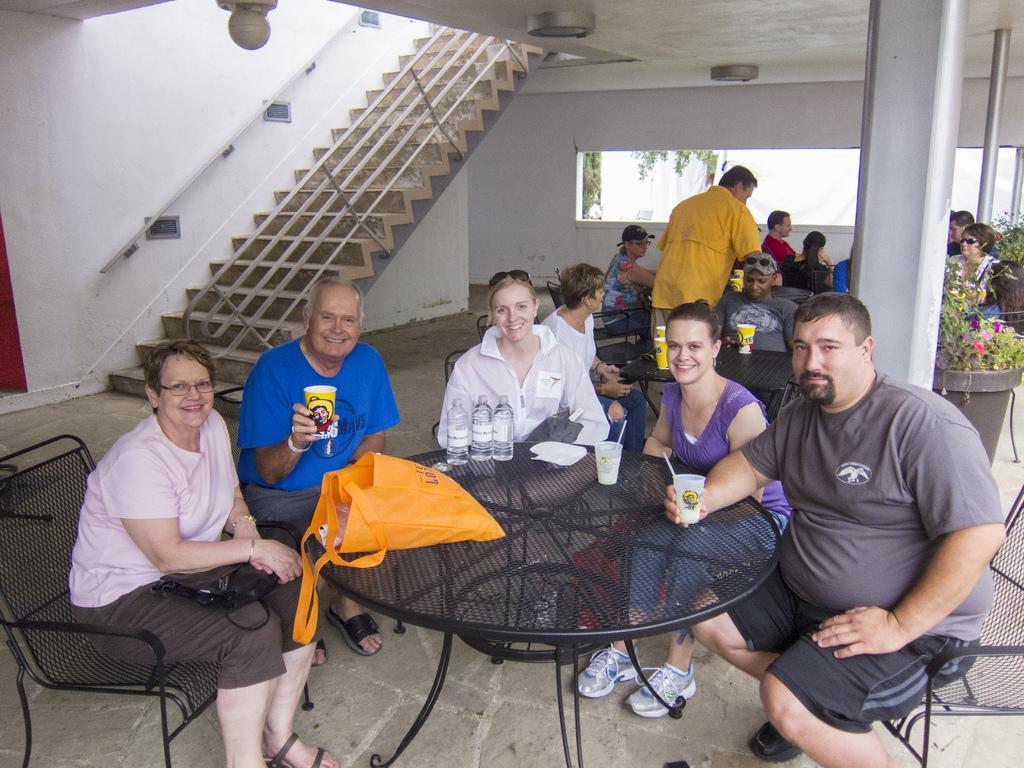Could you give a brief overview of what you see in this image? In this image i can see few people sitting on chairs in front of a table, on the table i can see few water bottles, a plate and few cups. In the background i can see few stairs, a wall, a pillar, few plants and a person standing. 